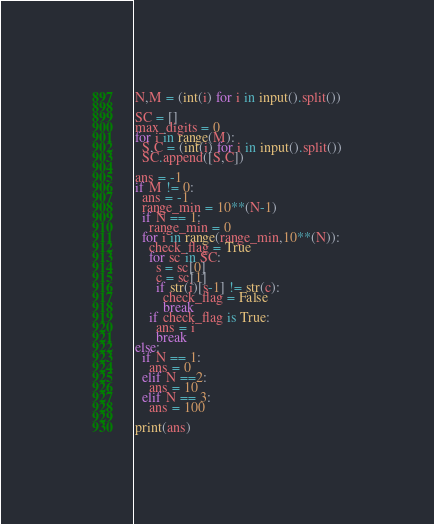<code> <loc_0><loc_0><loc_500><loc_500><_Python_>N,M = (int(i) for i in input().split())

SC = []
max_digits = 0
for i in range(M):
  S,C = (int(i) for i in input().split())
  SC.append([S,C])

ans = -1
if M != 0:
  ans = -1
  range_min = 10**(N-1)
  if N == 1:
    range_min = 0
  for i in range(range_min,10**(N)):
    check_flag = True
    for sc in SC:
      s = sc[0]
      c = sc[1]
      if str(i)[s-1] != str(c):
        check_flag = False
        break
    if check_flag is True:
      ans = i
      break
else:
  if N == 1:
    ans = 0
  elif N ==2:
    ans = 10
  elif N == 3:
    ans = 100

print(ans)
</code> 